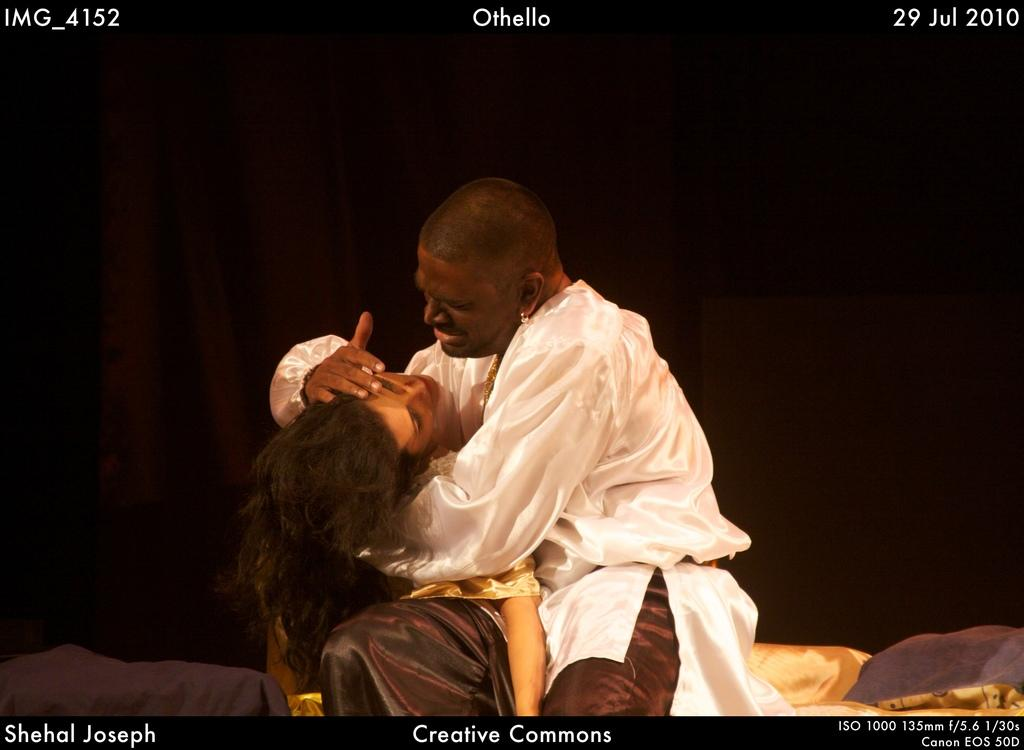Who is the main subject in the image? There is a man in the image. What is the man doing in the image? The man is sitting. What is the man wearing in the image? The man is wearing a white shirt. What is the man holding in the image? The man is holding a woman in his hands. What can be observed about the background of the image? The background of the image is dark. What type of impulse can be seen affecting the man in the image? There is no impulse affecting the man in the image; he is sitting calmly. Can you describe the bedroom in the image? There is no bedroom present in the image; it is a man sitting with a woman in his hands against a dark background. 